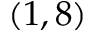<formula> <loc_0><loc_0><loc_500><loc_500>( 1 , 8 )</formula> 